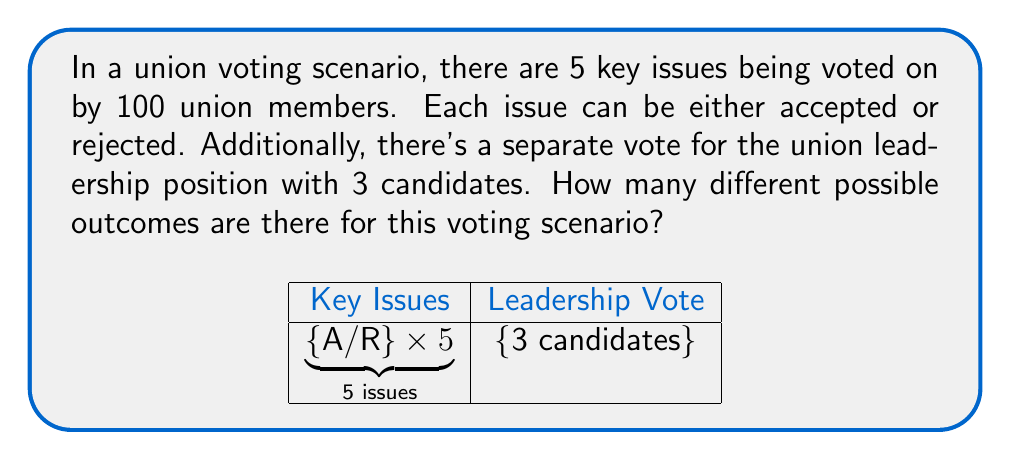Show me your answer to this math problem. Let's break this down step-by-step:

1) First, let's consider the 5 key issues:
   - Each issue has 2 possible outcomes (accept or reject)
   - There are 5 such issues
   - The number of possible outcomes for the issues is thus $2^5 = 32$

2) Now, for the leadership position:
   - There are 3 candidates
   - Each union member can vote for only one candidate
   - This is a separate vote from the issues

3) To find the total number of possible outcomes, we need to multiply:
   - The number of possible outcomes for the issues
   - The number of possible outcomes for the leadership vote

4) For the leadership vote:
   - With 100 voters and 3 candidates, this is a problem of distributing 100 indistinguishable objects (votes) into 3 distinguishable boxes (candidates)
   - This can be solved using the stars and bars method
   - The formula is $\binom{n+k-1}{k-1}$ where n is the number of objects and k is the number of boxes
   - In this case, $n = 100$ and $k = 3$
   - So we have: $\binom{100+3-1}{3-1} = \binom{102}{2}$

5) Calculate $\binom{102}{2}$:
   $$\binom{102}{2} = \frac{102!}{2!(102-2)!} = \frac{102 \times 101}{2} = 5151$$

6) Now, we multiply the results from steps 1 and 5:
   $32 \times 5151 = 164,832$

Therefore, the total number of possible outcomes is 164,832.
Answer: 164,832 